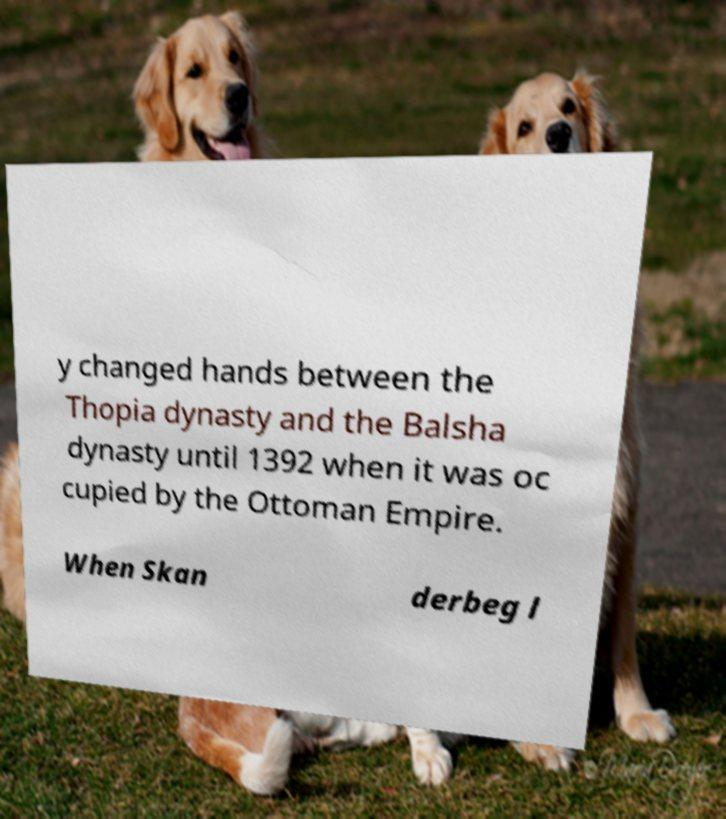What messages or text are displayed in this image? I need them in a readable, typed format. y changed hands between the Thopia dynasty and the Balsha dynasty until 1392 when it was oc cupied by the Ottoman Empire. When Skan derbeg l 